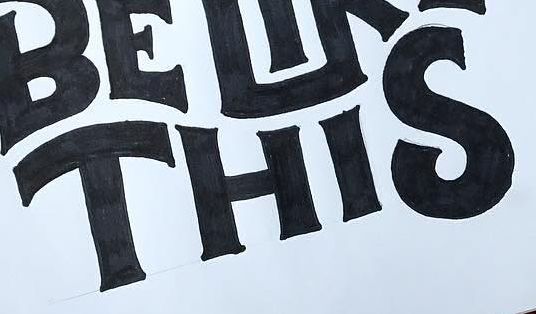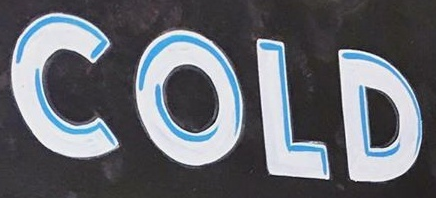Identify the words shown in these images in order, separated by a semicolon. THIS; COLD 